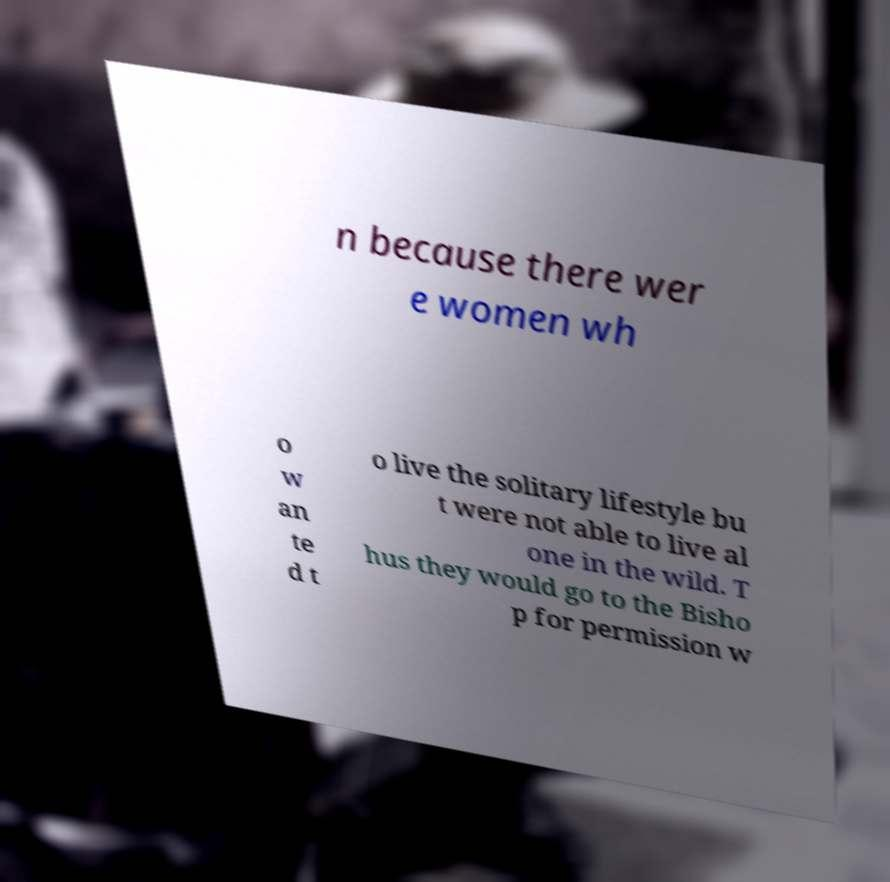Could you extract and type out the text from this image? n because there wer e women wh o w an te d t o live the solitary lifestyle bu t were not able to live al one in the wild. T hus they would go to the Bisho p for permission w 